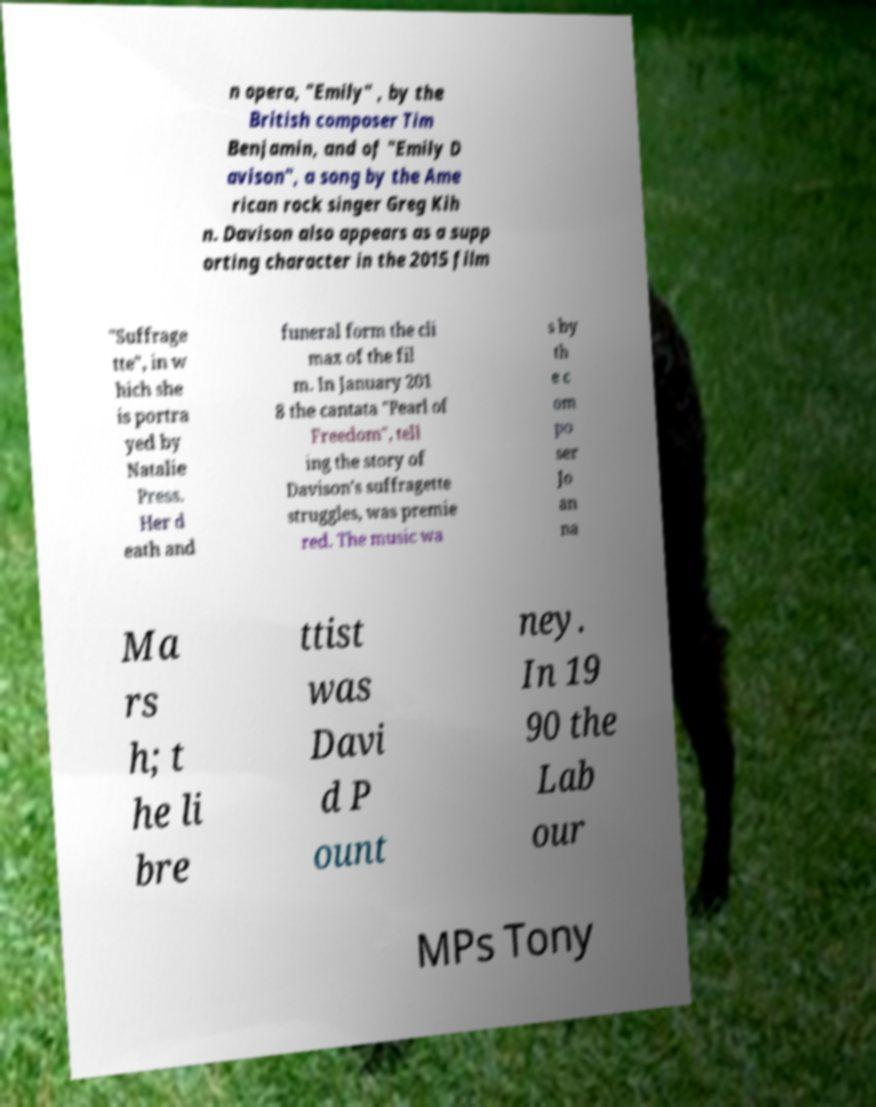Could you extract and type out the text from this image? n opera, "Emily" , by the British composer Tim Benjamin, and of "Emily D avison", a song by the Ame rican rock singer Greg Kih n. Davison also appears as a supp orting character in the 2015 film "Suffrage tte", in w hich she is portra yed by Natalie Press. Her d eath and funeral form the cli max of the fil m. In January 201 8 the cantata "Pearl of Freedom", tell ing the story of Davison's suffragette struggles, was premie red. The music wa s by th e c om po ser Jo an na Ma rs h; t he li bre ttist was Davi d P ount ney. In 19 90 the Lab our MPs Tony 